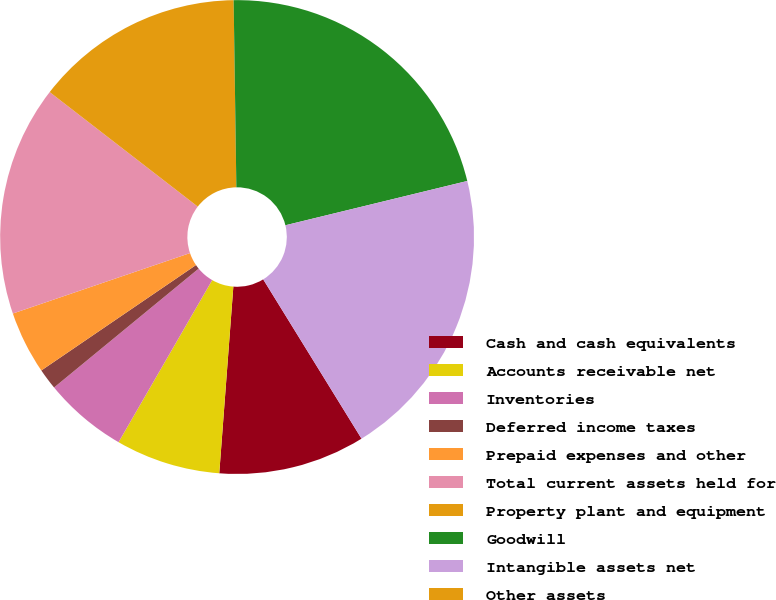Convert chart. <chart><loc_0><loc_0><loc_500><loc_500><pie_chart><fcel>Cash and cash equivalents<fcel>Accounts receivable net<fcel>Inventories<fcel>Deferred income taxes<fcel>Prepaid expenses and other<fcel>Total current assets held for<fcel>Property plant and equipment<fcel>Goodwill<fcel>Intangible assets net<fcel>Other assets<nl><fcel>10.0%<fcel>7.14%<fcel>5.71%<fcel>1.43%<fcel>4.29%<fcel>15.71%<fcel>14.29%<fcel>21.43%<fcel>20.0%<fcel>0.0%<nl></chart> 